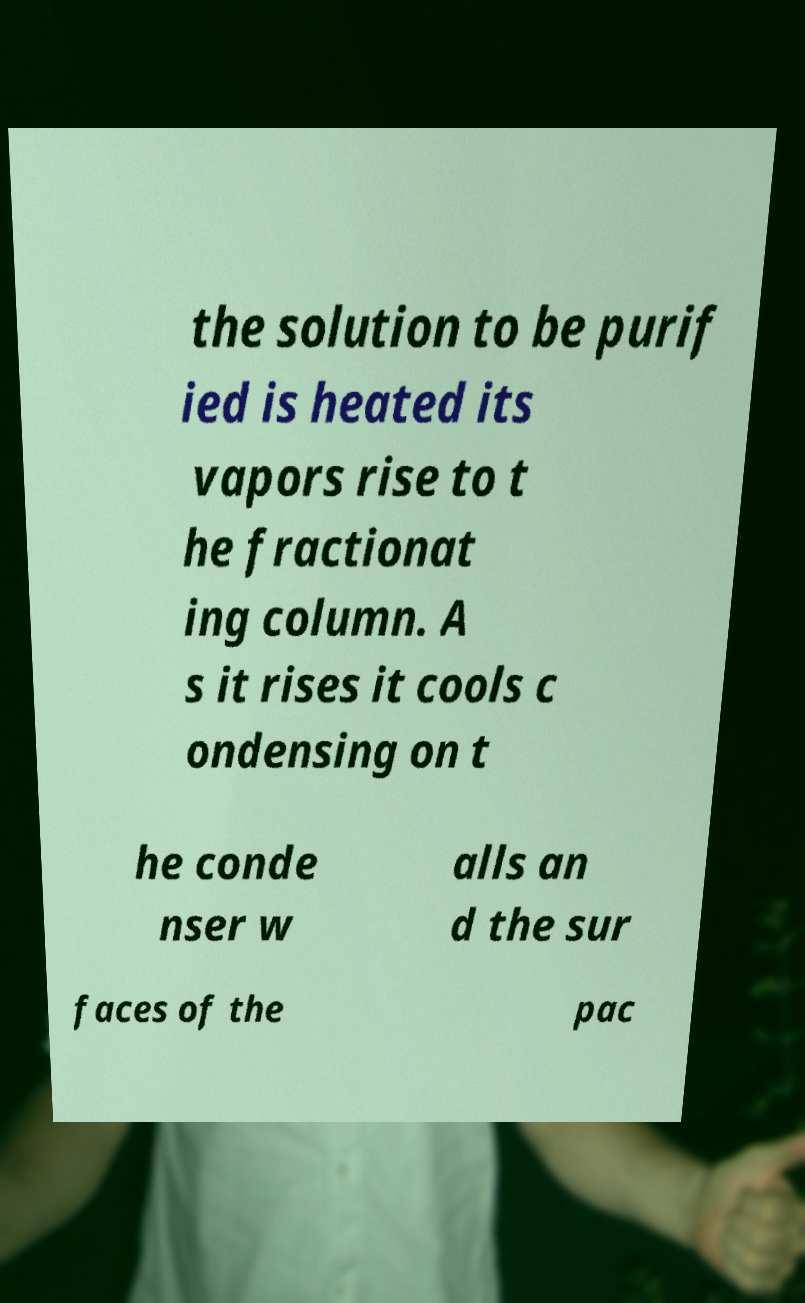Can you read and provide the text displayed in the image?This photo seems to have some interesting text. Can you extract and type it out for me? the solution to be purif ied is heated its vapors rise to t he fractionat ing column. A s it rises it cools c ondensing on t he conde nser w alls an d the sur faces of the pac 